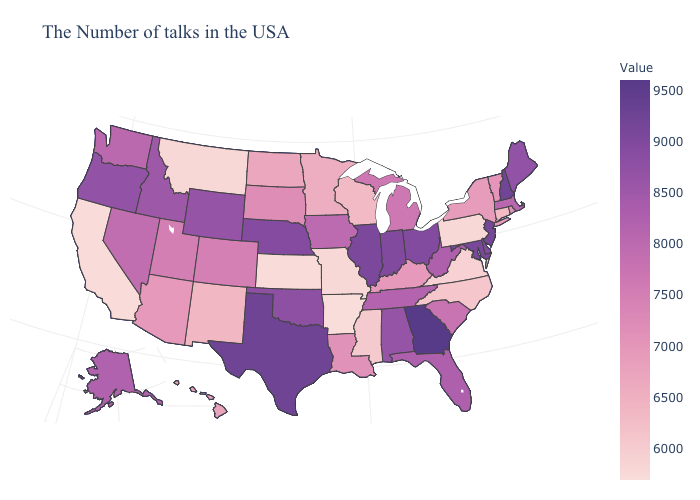Does Wisconsin have a higher value than Alaska?
Keep it brief. No. Among the states that border Iowa , which have the highest value?
Give a very brief answer. Illinois. Among the states that border Texas , does New Mexico have the lowest value?
Quick response, please. No. Does South Carolina have the highest value in the South?
Answer briefly. No. 